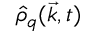Convert formula to latex. <formula><loc_0><loc_0><loc_500><loc_500>\hat { \rho } _ { q } ( \vec { k } , t )</formula> 